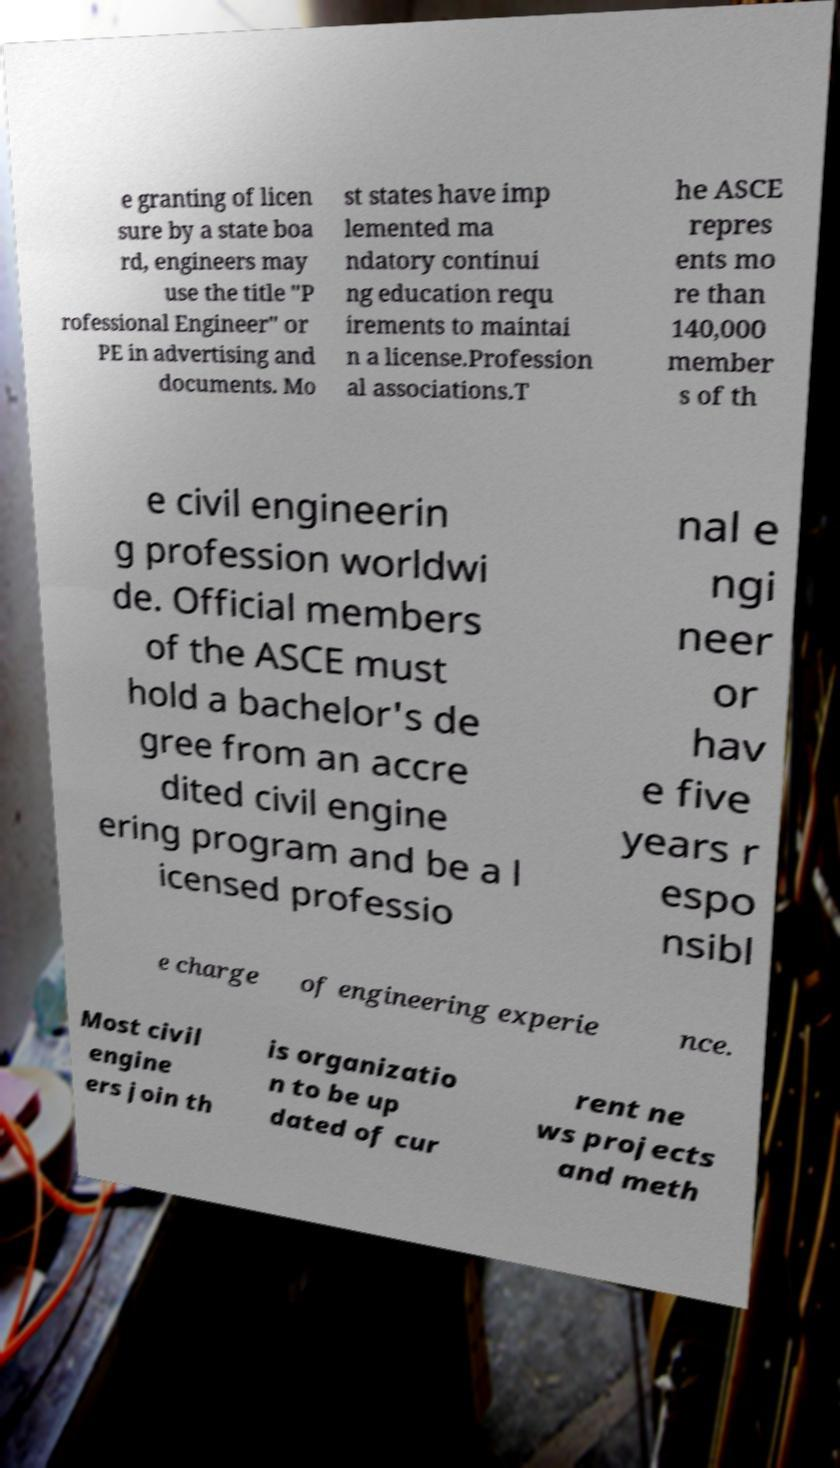Please identify and transcribe the text found in this image. e granting of licen sure by a state boa rd, engineers may use the title "P rofessional Engineer" or PE in advertising and documents. Mo st states have imp lemented ma ndatory continui ng education requ irements to maintai n a license.Profession al associations.T he ASCE repres ents mo re than 140,000 member s of th e civil engineerin g profession worldwi de. Official members of the ASCE must hold a bachelor's de gree from an accre dited civil engine ering program and be a l icensed professio nal e ngi neer or hav e five years r espo nsibl e charge of engineering experie nce. Most civil engine ers join th is organizatio n to be up dated of cur rent ne ws projects and meth 